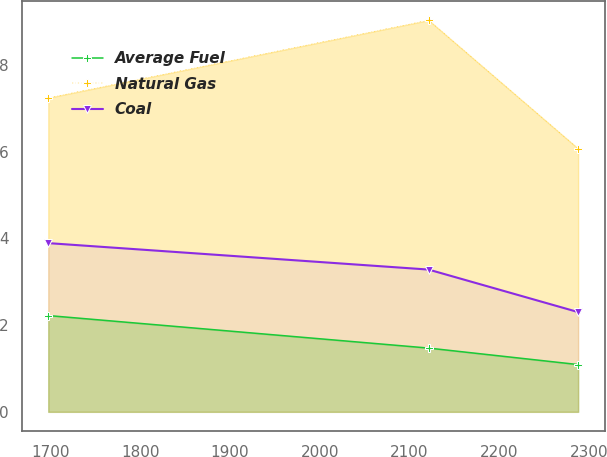<chart> <loc_0><loc_0><loc_500><loc_500><line_chart><ecel><fcel>Average Fuel<fcel>Natural Gas<fcel>Coal<nl><fcel>1697.46<fcel>2.22<fcel>7.24<fcel>3.89<nl><fcel>2121.28<fcel>1.47<fcel>9.03<fcel>3.28<nl><fcel>2287.87<fcel>1.09<fcel>6.07<fcel>2.3<nl></chart> 